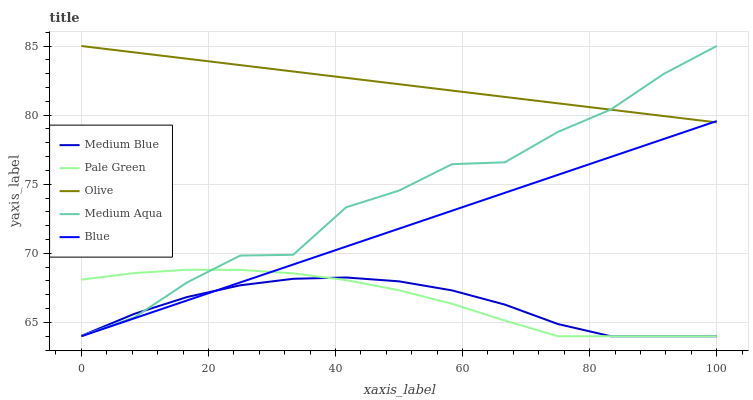Does Medium Blue have the minimum area under the curve?
Answer yes or no. Yes. Does Olive have the maximum area under the curve?
Answer yes or no. Yes. Does Medium Aqua have the minimum area under the curve?
Answer yes or no. No. Does Medium Aqua have the maximum area under the curve?
Answer yes or no. No. Is Blue the smoothest?
Answer yes or no. Yes. Is Medium Aqua the roughest?
Answer yes or no. Yes. Is Pale Green the smoothest?
Answer yes or no. No. Is Pale Green the roughest?
Answer yes or no. No. Does Pale Green have the lowest value?
Answer yes or no. Yes. Does Medium Aqua have the lowest value?
Answer yes or no. No. Does Medium Aqua have the highest value?
Answer yes or no. Yes. Does Pale Green have the highest value?
Answer yes or no. No. Is Blue less than Medium Aqua?
Answer yes or no. Yes. Is Medium Aqua greater than Blue?
Answer yes or no. Yes. Does Blue intersect Medium Blue?
Answer yes or no. Yes. Is Blue less than Medium Blue?
Answer yes or no. No. Is Blue greater than Medium Blue?
Answer yes or no. No. Does Blue intersect Medium Aqua?
Answer yes or no. No. 